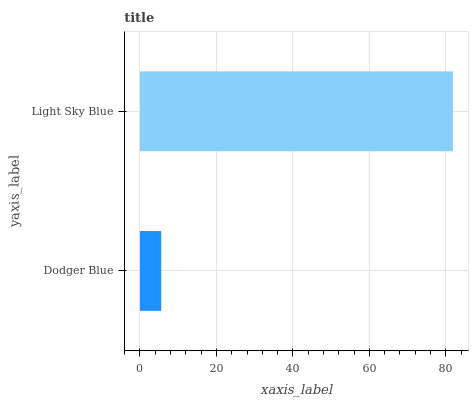Is Dodger Blue the minimum?
Answer yes or no. Yes. Is Light Sky Blue the maximum?
Answer yes or no. Yes. Is Light Sky Blue the minimum?
Answer yes or no. No. Is Light Sky Blue greater than Dodger Blue?
Answer yes or no. Yes. Is Dodger Blue less than Light Sky Blue?
Answer yes or no. Yes. Is Dodger Blue greater than Light Sky Blue?
Answer yes or no. No. Is Light Sky Blue less than Dodger Blue?
Answer yes or no. No. Is Light Sky Blue the high median?
Answer yes or no. Yes. Is Dodger Blue the low median?
Answer yes or no. Yes. Is Dodger Blue the high median?
Answer yes or no. No. Is Light Sky Blue the low median?
Answer yes or no. No. 